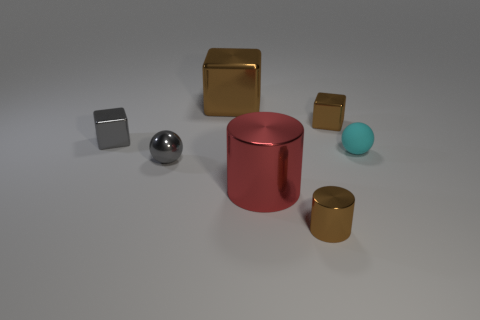What number of other things are made of the same material as the red thing?
Your response must be concise. 5. Is the size of the gray block the same as the red thing?
Provide a succinct answer. No. The brown thing in front of the tiny cyan sphere has what shape?
Keep it short and to the point. Cylinder. What is the color of the tiny cube that is in front of the small cube that is on the right side of the big red metal cylinder?
Ensure brevity in your answer.  Gray. There is a tiny metal object in front of the gray ball; is its shape the same as the brown thing that is left of the brown cylinder?
Give a very brief answer. No. What is the shape of the gray metallic object that is the same size as the gray shiny block?
Your answer should be compact. Sphere. There is a big block that is made of the same material as the small gray sphere; what color is it?
Give a very brief answer. Brown. There is a tiny rubber thing; is its shape the same as the big shiny thing that is in front of the large brown metal object?
Provide a succinct answer. No. There is a big cube that is the same color as the tiny metallic cylinder; what material is it?
Provide a succinct answer. Metal. What material is the cyan sphere that is the same size as the gray sphere?
Your response must be concise. Rubber. 